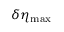Convert formula to latex. <formula><loc_0><loc_0><loc_500><loc_500>\delta \eta _ { \max }</formula> 